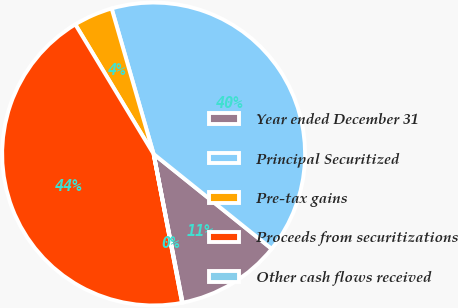Convert chart to OTSL. <chart><loc_0><loc_0><loc_500><loc_500><pie_chart><fcel>Year ended December 31<fcel>Principal Securitized<fcel>Pre-tax gains<fcel>Proceeds from securitizations<fcel>Other cash flows received<nl><fcel>11.16%<fcel>40.24%<fcel>4.18%<fcel>44.36%<fcel>0.06%<nl></chart> 